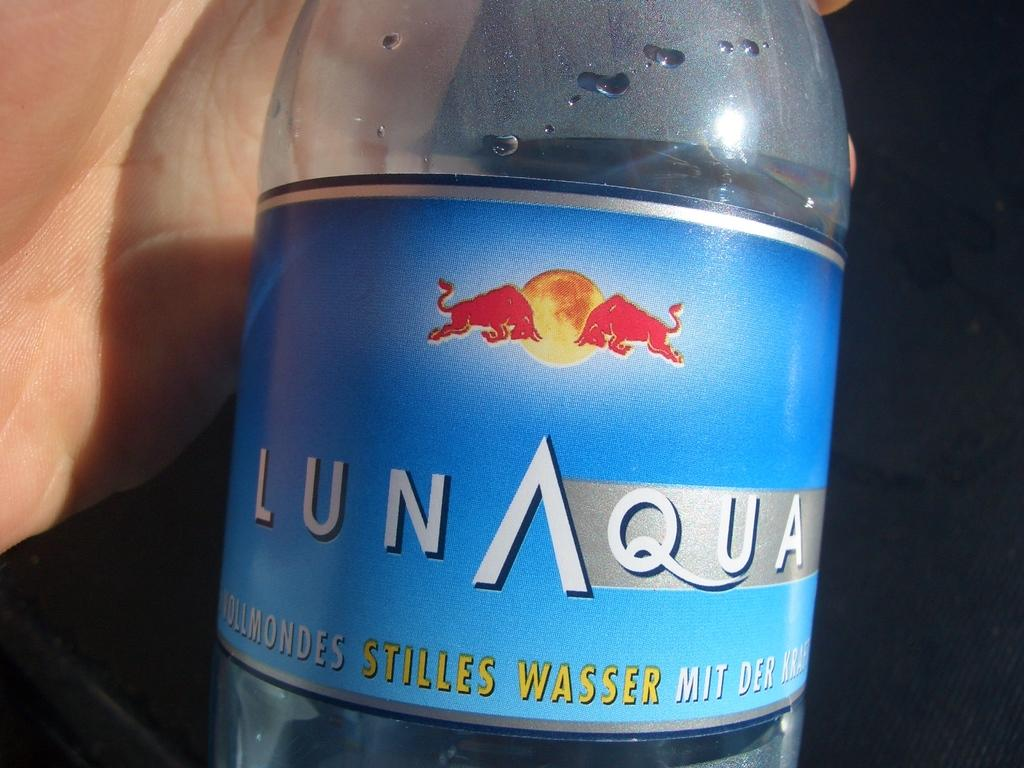What object can be seen in the image? There is a bottle in the image. What part of a person is visible in the image? There is a human hand in the image. What type of rain is falling in the image? There is no rain present in the image. What kind of spy equipment can be seen in the image? There is no spy equipment present in the image. 